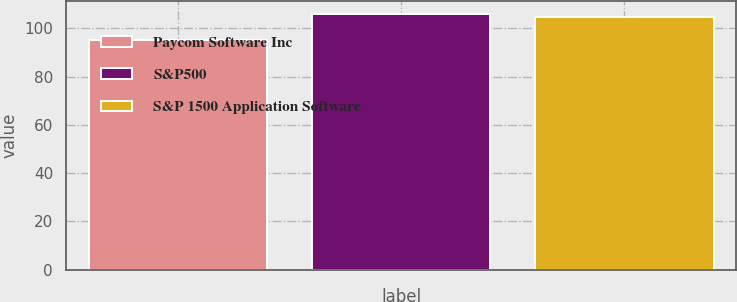Convert chart. <chart><loc_0><loc_0><loc_500><loc_500><bar_chart><fcel>Paycom Software Inc<fcel>S&P500<fcel>S&P 1500 Application Software<nl><fcel>95.05<fcel>105.94<fcel>104.92<nl></chart> 